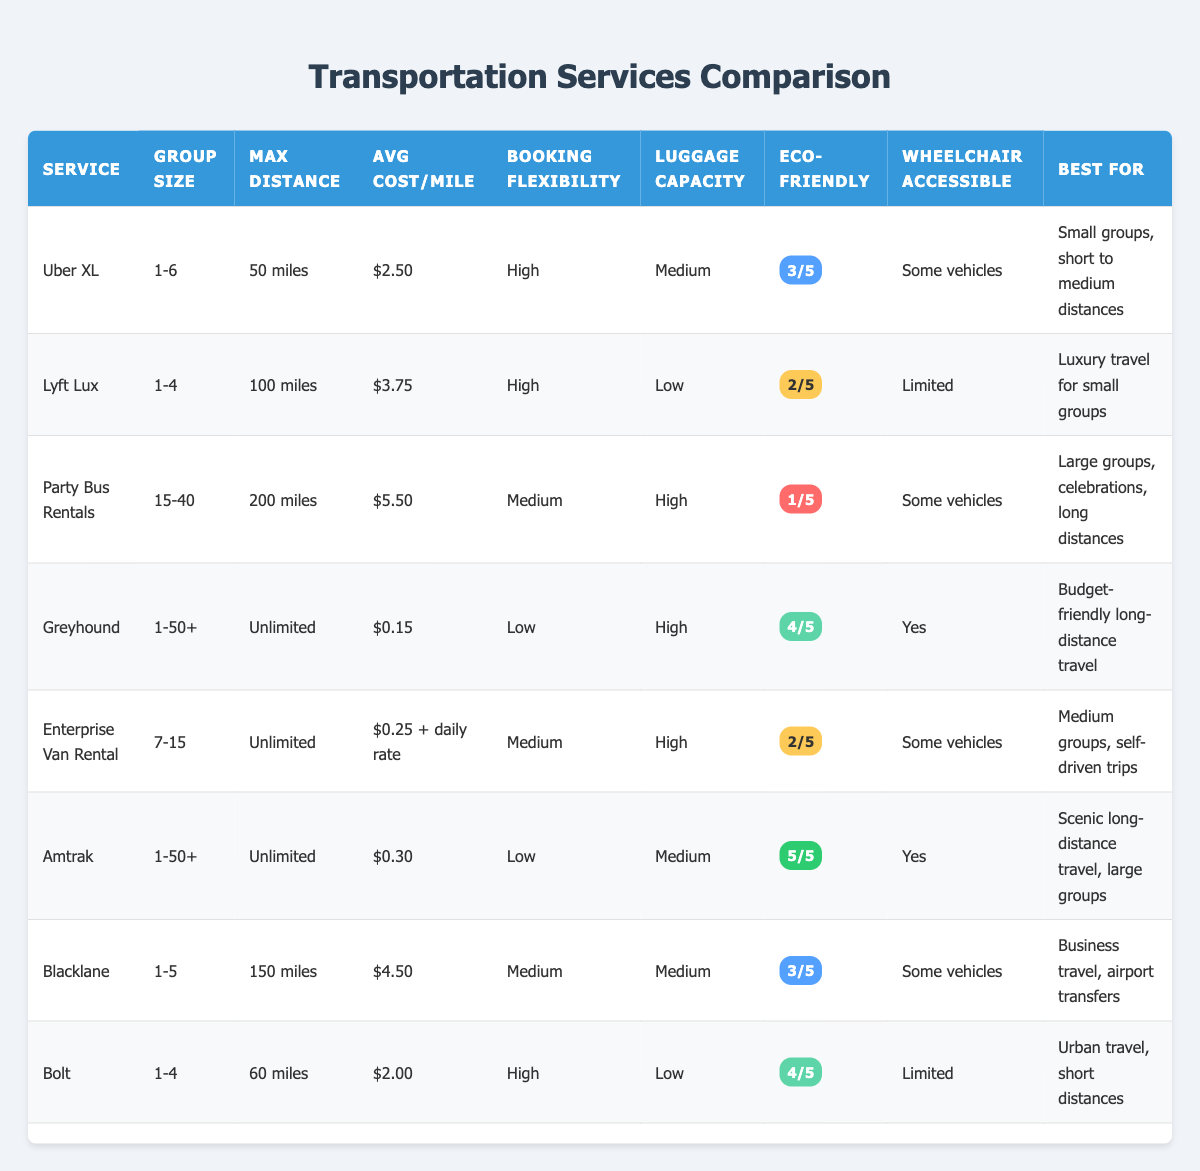What is the maximum distance for Party Bus Rentals? The table lists the max distance for Party Bus Rentals, which is specified as 200 miles.
Answer: 200 miles Which transportation service has the highest average cost per mile? By looking at the "Avg Cost/Mile" column, Party Bus Rentals has the highest average cost at $5.50.
Answer: Party Bus Rentals How many services are suitable for groups of 1-4 people? There are three services that accommodate 1-4 people: Lyft Lux, Bolt, and Blacklane.
Answer: 3 Is Uber XL wheelchair accessible? The table indicates that Uber XL has "Some vehicles" that are wheelchair accessible, confirming that it is partially accessible.
Answer: Yes What is the average eco-friendly rating for services that accommodate 1-4 people? The eco-friendly ratings for 1-4 person services (Lyft Lux: 2/5, Bolt: 4/5, Blacklane: 3/5) are summed up: (2 + 4 + 3) = 9, and divided by 3 to find the average: 9 / 3 = 3.
Answer: 3 Which service is best for scenic long-distance travel for large groups? Amtrak is identified in the table as the best for scenic long-distance travel and accommodates large groups (1-50+).
Answer: Amtrak What is the luggage capacity for services that offer high capacity? The services with high luggage capacity are Greyhound, Party Bus Rentals, and Enterprise Van Rental.
Answer: 3 services How does the booking flexibility of Greyhound compare to Uber XL? The booking flexibility of Greyhound is categorized as low, while Uber XL has high booking flexibility. Hence, Uber XL offers more flexibility.
Answer: Uber XL has more flexibility Which two services have an eco-friendly rating higher than 3/5? Among the services listed, only Amtrak (5/5) and Greyhound (4/5) have eco-friendly ratings higher than 3/5.
Answer: 2 services 